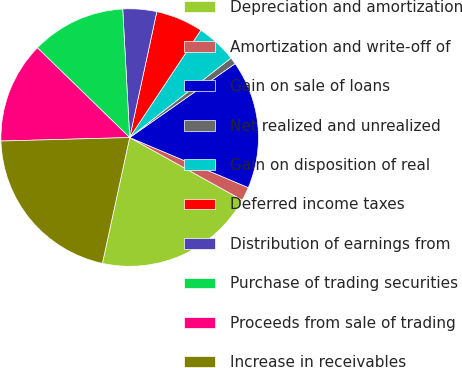Convert chart. <chart><loc_0><loc_0><loc_500><loc_500><pie_chart><fcel>Depreciation and amortization<fcel>Amortization and write-off of<fcel>Gain on sale of loans<fcel>Net realized and unrealized<fcel>Gain on disposition of real<fcel>Deferred income taxes<fcel>Distribution of earnings from<fcel>Purchase of trading securities<fcel>Proceeds from sale of trading<fcel>Increase in receivables<nl><fcel>20.33%<fcel>1.71%<fcel>16.09%<fcel>0.86%<fcel>5.09%<fcel>5.94%<fcel>4.24%<fcel>11.86%<fcel>12.71%<fcel>21.17%<nl></chart> 